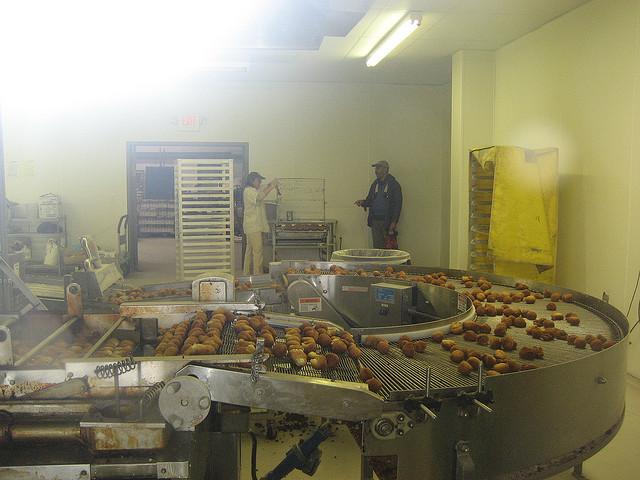What are the people doing?
Short answer required. Working. Is it safe to sit on this machine?
Give a very brief answer. No. What is on the silver stand?
Keep it brief. Food. What food is being processed?
Concise answer only. Potatoes. What is on the wall?
Give a very brief answer. Paint. Is this a canning factory?
Short answer required. No. 